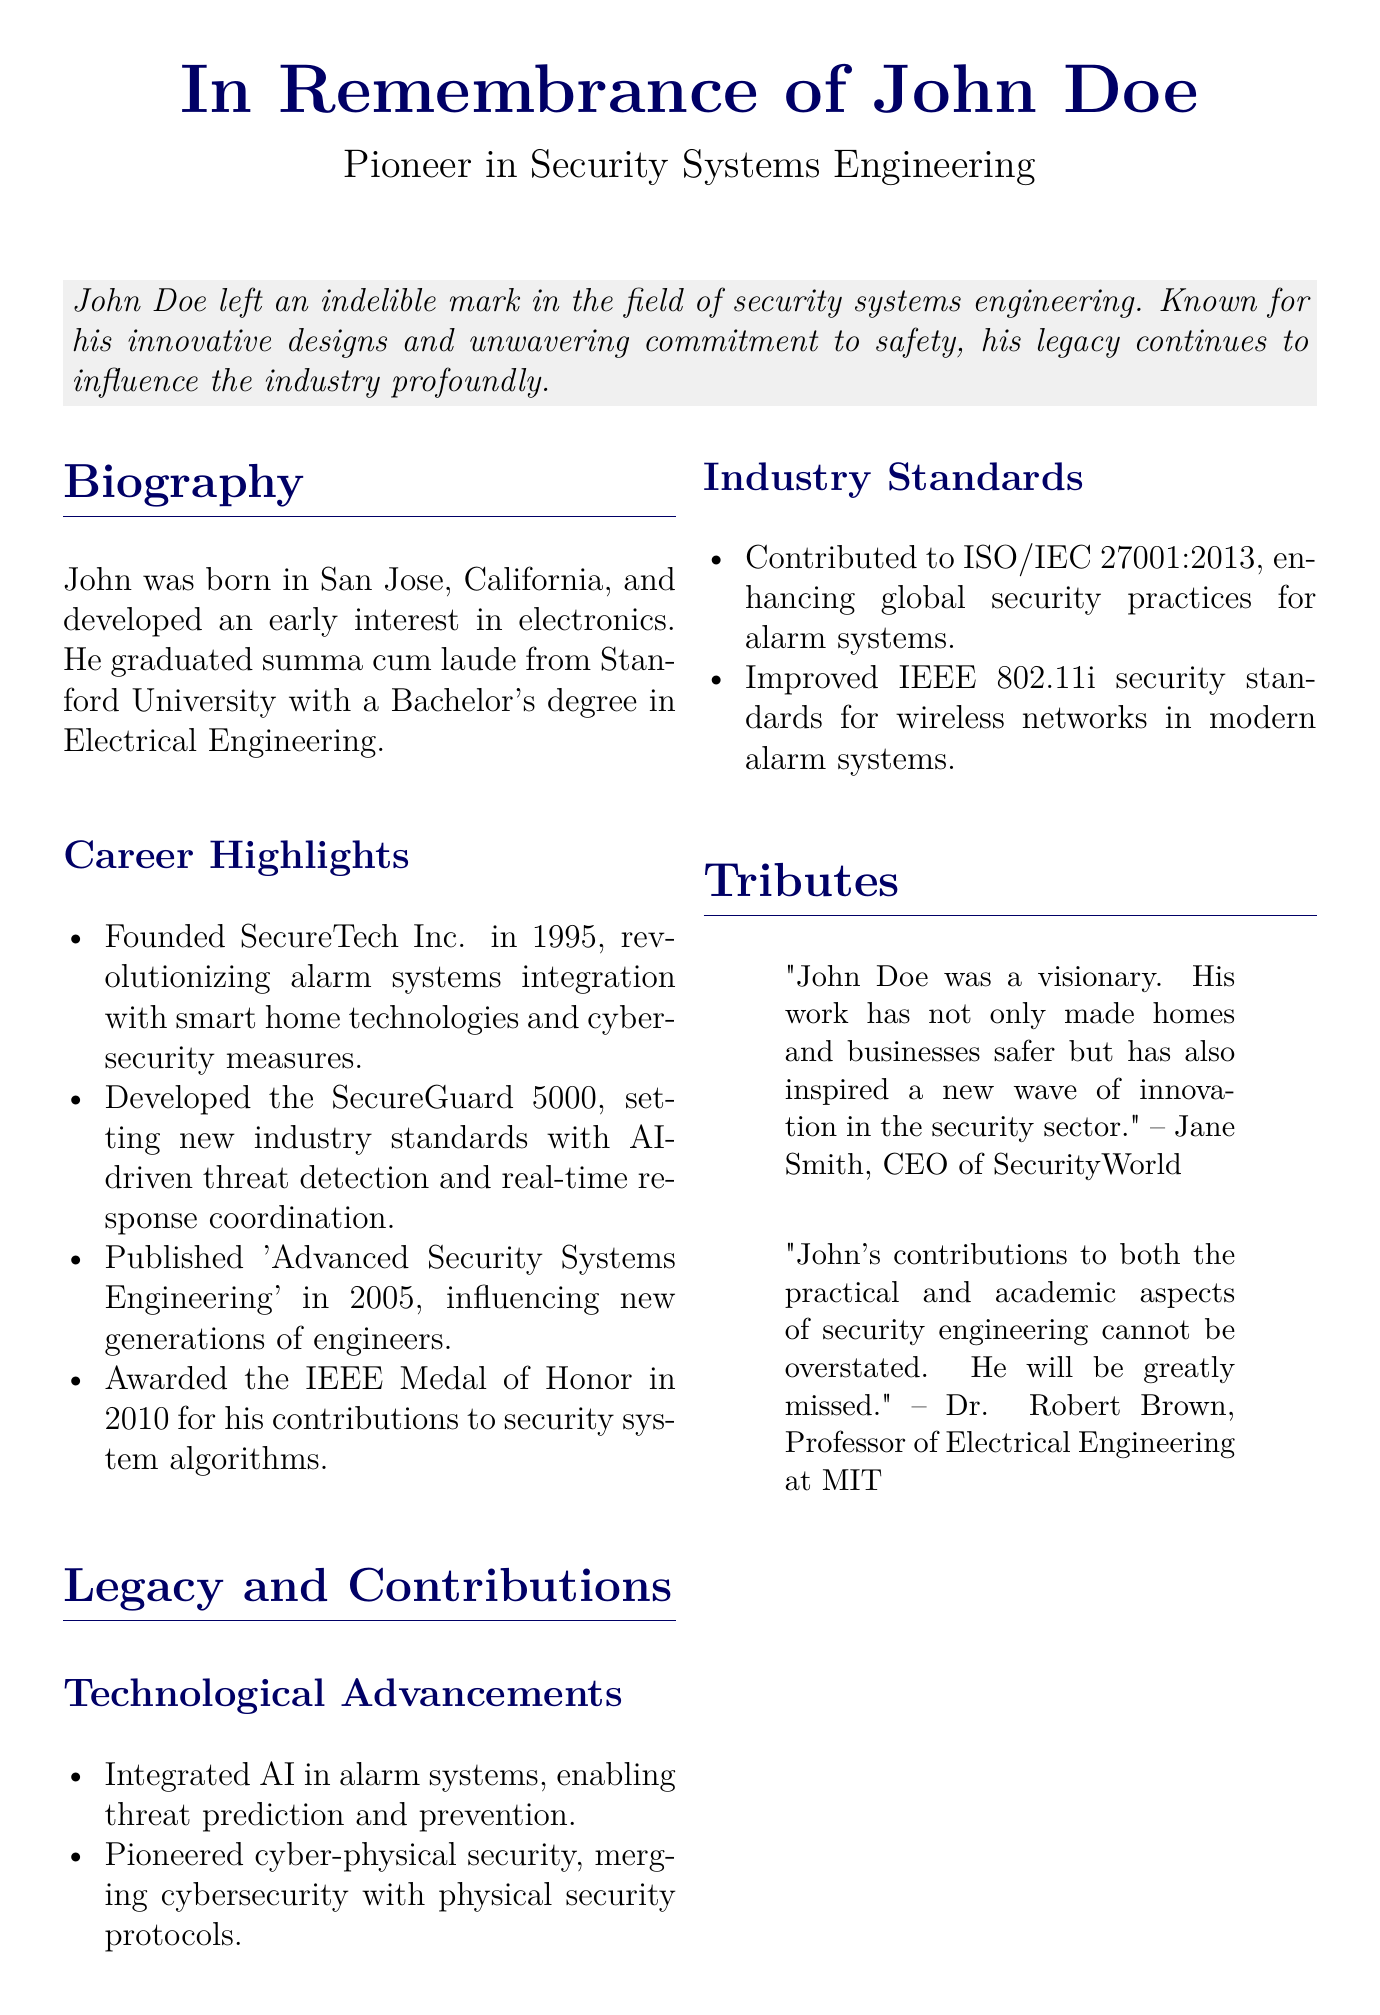What was John Doe's field of expertise? John Doe was known for his work in security systems engineering.
Answer: security systems engineering What was the name of the company John Doe founded? John Doe founded SecureTech Inc. in 1995.
Answer: SecureTech Inc What significant award did John Doe receive in 2010? He was awarded the IEEE Medal of Honor in 2010 for his contributions to security system algorithms.
Answer: IEEE Medal of Honor What technology did John Doe integrate into alarm systems? He integrated AI in alarm systems for threat prediction and prevention.
Answer: AI Which book did John Doe publish in 2005? He published 'Advanced Security Systems Engineering' in 2005.
Answer: Advanced Security Systems Engineering What is one of the contributions John made to industry standards? He contributed to ISO/IEC 27001:2013, enhancing global security practices for alarm systems.
Answer: ISO/IEC 27001:2013 Who is quoted as saying John was a visionary? Jane Smith, CEO of SecurityWorld, mentioned that John was a visionary.
Answer: Jane Smith In what year did John Doe graduate from Stanford University? The document does not specify the graduation year from Stanford University.
Answer: Not specified What was one of the main advancements in alarm systems credited to John Doe? He developed the SecureGuard 5000, which set new industry standards.
Answer: SecureGuard 5000 